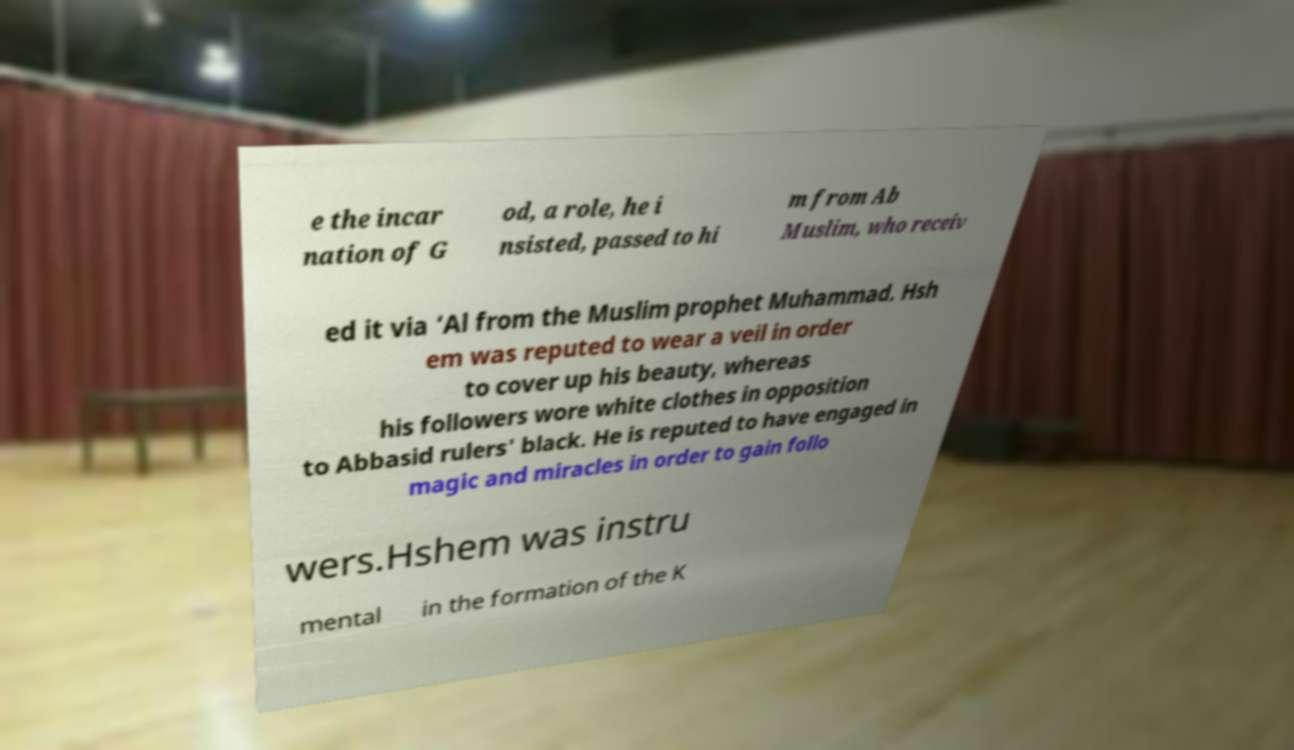Please read and relay the text visible in this image. What does it say? e the incar nation of G od, a role, he i nsisted, passed to hi m from Ab Muslim, who receiv ed it via ‘Al from the Muslim prophet Muhammad. Hsh em was reputed to wear a veil in order to cover up his beauty, whereas his followers wore white clothes in opposition to Abbasid rulers' black. He is reputed to have engaged in magic and miracles in order to gain follo wers.Hshem was instru mental in the formation of the K 